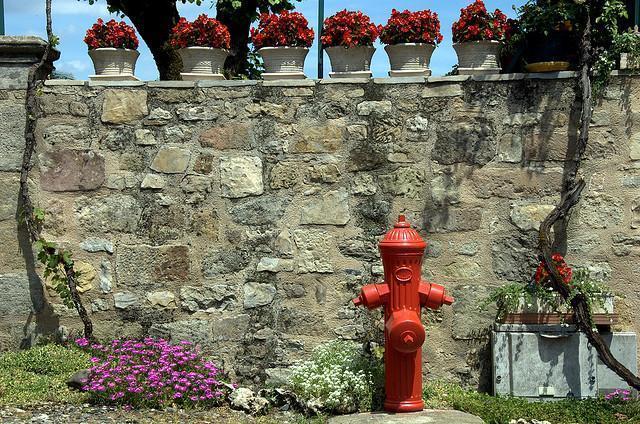How many potted plants can be seen?
Give a very brief answer. 8. How many black umbrella are there?
Give a very brief answer. 0. 